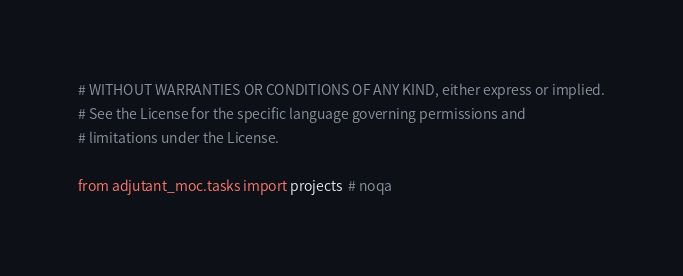<code> <loc_0><loc_0><loc_500><loc_500><_Python_># WITHOUT WARRANTIES OR CONDITIONS OF ANY KIND, either express or implied.
# See the License for the specific language governing permissions and
# limitations under the License.

from adjutant_moc.tasks import projects  # noqa
</code> 